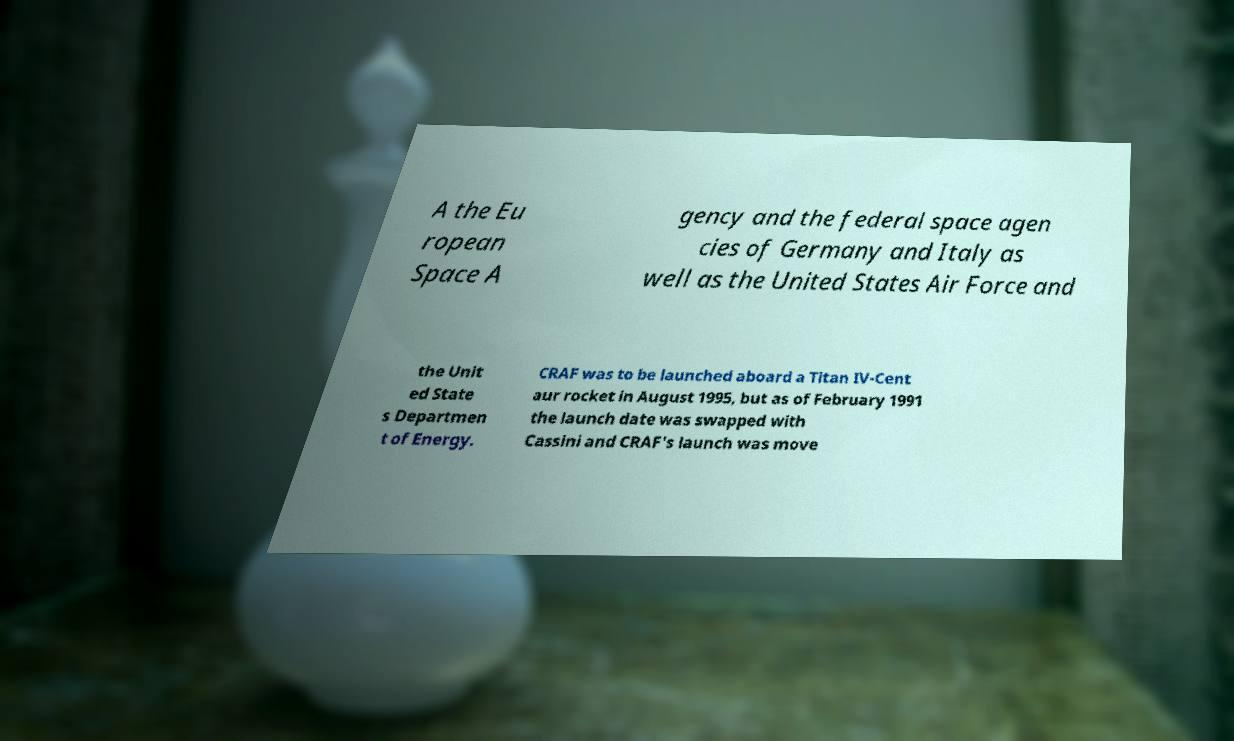Please identify and transcribe the text found in this image. A the Eu ropean Space A gency and the federal space agen cies of Germany and Italy as well as the United States Air Force and the Unit ed State s Departmen t of Energy. CRAF was to be launched aboard a Titan IV-Cent aur rocket in August 1995, but as of February 1991 the launch date was swapped with Cassini and CRAF's launch was move 